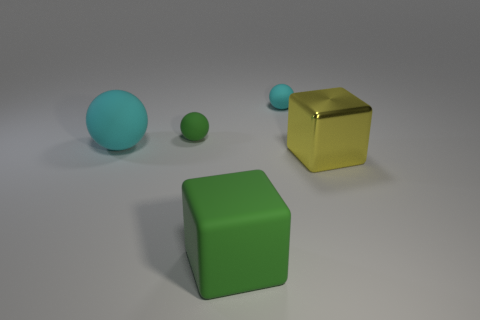Subtract all large cyan spheres. How many spheres are left? 2 Subtract all balls. How many objects are left? 2 Subtract 0 yellow cylinders. How many objects are left? 5 Subtract 2 balls. How many balls are left? 1 Subtract all yellow cubes. Subtract all purple balls. How many cubes are left? 1 Subtract all blue balls. How many green cubes are left? 1 Subtract all brown rubber things. Subtract all cyan matte balls. How many objects are left? 3 Add 5 tiny green things. How many tiny green things are left? 6 Add 4 green rubber balls. How many green rubber balls exist? 5 Add 2 large red matte objects. How many objects exist? 7 